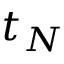Convert formula to latex. <formula><loc_0><loc_0><loc_500><loc_500>t _ { N }</formula> 